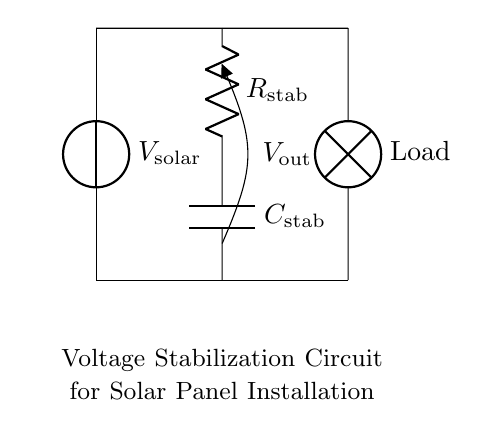What are the components in this circuit? The circuit contains a solar voltage source, a resistor, a capacitor, and a load labeled as 'Lamp'. Each component is clearly labeled in the diagram.
Answer: Solar voltage source, resistor, capacitor, lamp What is the role of the capacitor in this circuit? The capacitor in a resistor-capacitor circuit stabilizes the voltage output by smoothing fluctuations, effectively storing and releasing energy as needed to maintain steady voltage to the load.
Answer: Voltage stabilization What is the purpose of the resistor in this circuit? The resistor functions to limit the current flow and work in tandem with the capacitor to create the conditions necessary for voltage stabilization across the load.
Answer: Current limiting What is the output voltage labeled as in this circuit? The output voltage from the circuit is specifically designated as V out, which is the voltage available to the load connected.
Answer: V out How does the configuration of this circuit help in solar panel installations? This configuration effectively manages the variable output from the solar panels, ensuring that the connected load receives a stable voltage, which is vital for consistent performance of any electrical device.
Answer: Voltage stabilization What happens to the output voltage during load variation? During load variation, the capacitor helps maintain a stable output voltage by compensating for sudden changes in load, thus smoothing the output voltage provided to the lamp.
Answer: Stabilized output voltage 